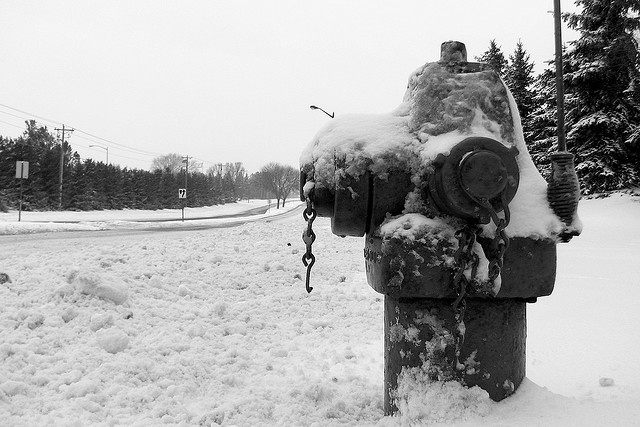Describe the objects in this image and their specific colors. I can see a fire hydrant in white, black, gray, darkgray, and lightgray tones in this image. 